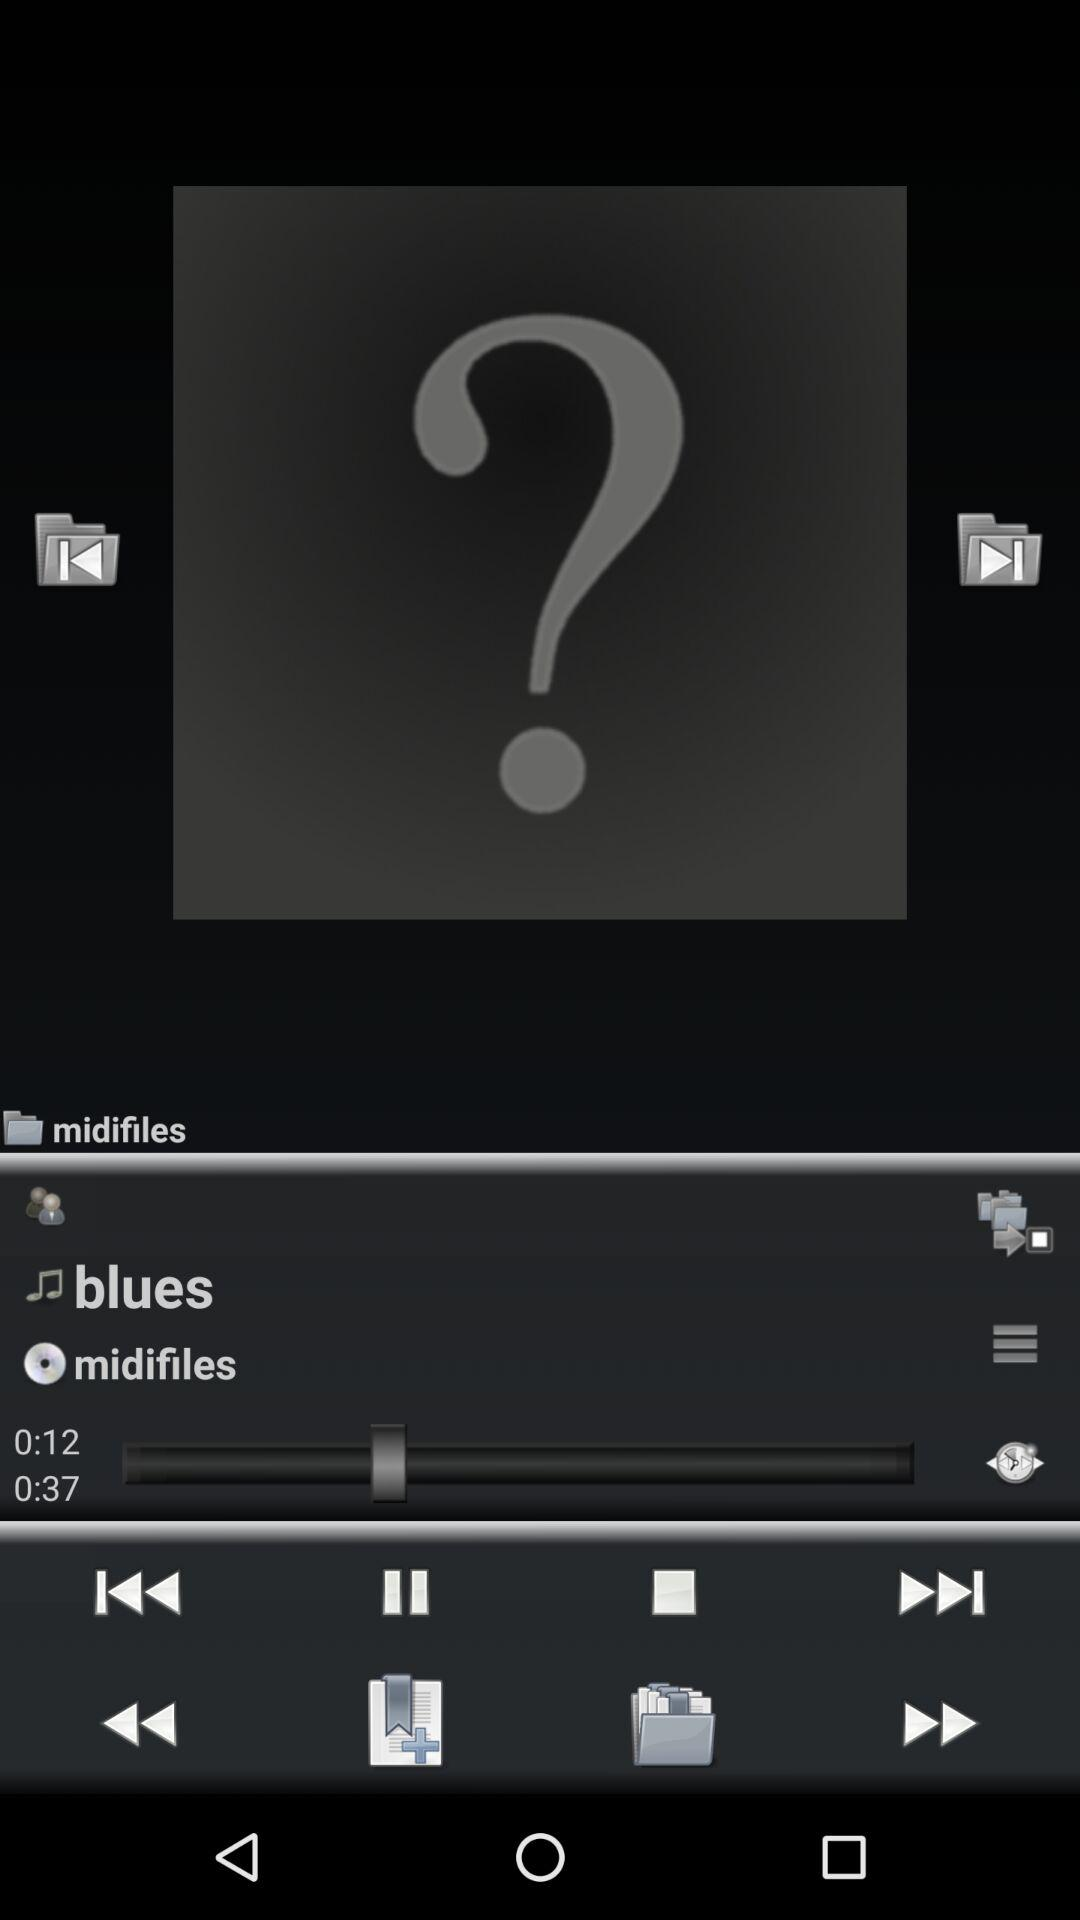What is the length of the currently playing audio? The length of the currently playing audio is 37 seconds. 